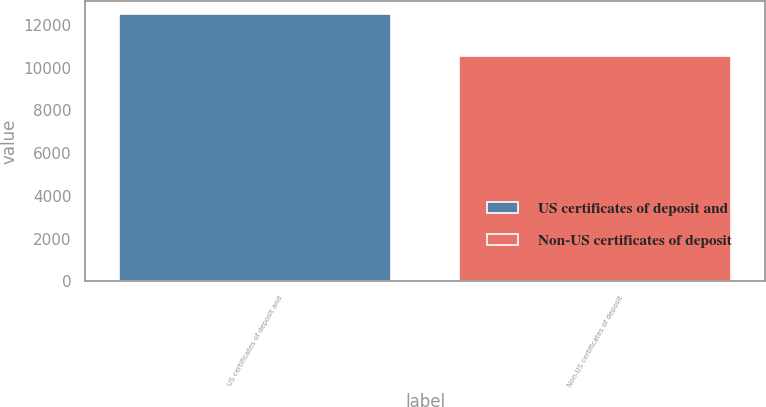<chart> <loc_0><loc_0><loc_500><loc_500><bar_chart><fcel>US certificates of deposit and<fcel>Non-US certificates of deposit<nl><fcel>12505<fcel>10561<nl></chart> 